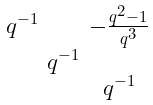Convert formula to latex. <formula><loc_0><loc_0><loc_500><loc_500>\begin{smallmatrix} q ^ { - 1 } & & - \frac { q ^ { 2 } - 1 } { q ^ { 3 } } \\ & q ^ { - 1 } & \\ & & q ^ { - 1 } \end{smallmatrix}</formula> 